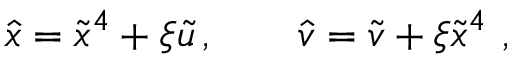Convert formula to latex. <formula><loc_0><loc_0><loc_500><loc_500>\hat { x } = \tilde { x } ^ { 4 } + \xi \tilde { u } \, , \quad \hat { v } = \tilde { v } + \xi \tilde { x } ^ { 4 } \ ,</formula> 